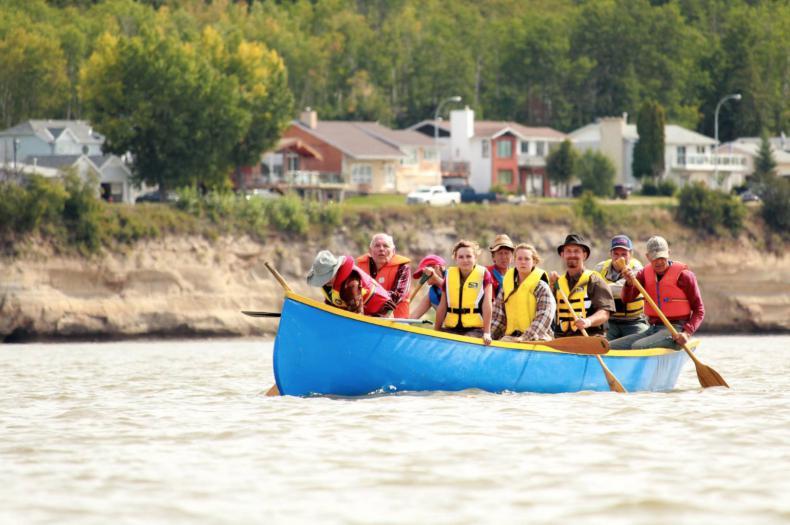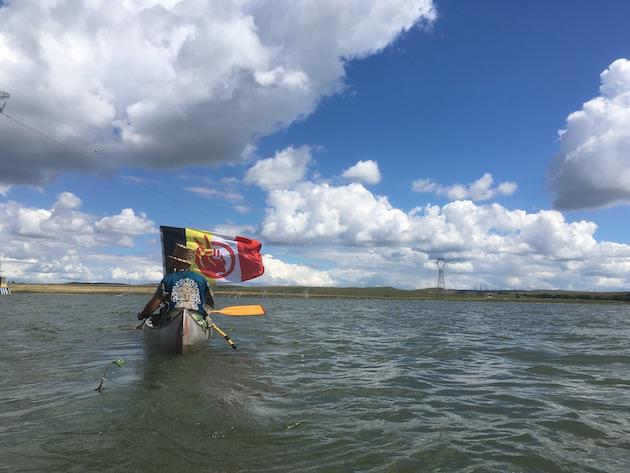The first image is the image on the left, the second image is the image on the right. Assess this claim about the two images: "Each image shows just one boat in the foreground.". Correct or not? Answer yes or no. Yes. The first image is the image on the left, the second image is the image on the right. Analyze the images presented: Is the assertion "One of the images shows an American Indian Movement flag with black, yellow, white, and red stripes and a red logo." valid? Answer yes or no. Yes. 